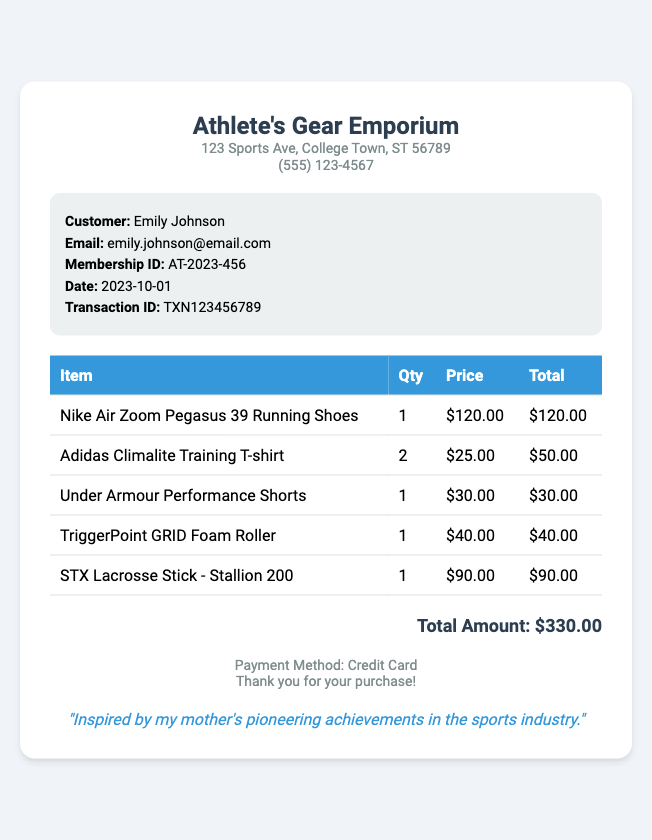What is the store name? The store name is mentioned at the top of the document as the title, which reflects the business's name.
Answer: Athlete's Gear Emporium Who is the customer? The customer's name is provided in the customer information section of the receipt.
Answer: Emily Johnson What is the total amount? The total amount is clearly stated at the end of the transaction details, summarizing the cost of all purchased items.
Answer: $330.00 How many Adidas Climalite Training T-shirts were purchased? The quantity of the Adidas T-shirts can be found in the table detailing each item in the transaction.
Answer: 2 What is the date of the transaction? The transaction date is prominently displayed in the customer information section of the receipt.
Answer: 2023-10-01 What payment method was used? The payment method is mentioned at the bottom of the document in the footer section.
Answer: Credit Card What is the price of the Nike Air Zoom Pegasus 39 Running Shoes? The price for the running shoes is listed in the price column of the item table.
Answer: $120.00 How many items were purchased in total? The total number of items can be calculated from the quantity column in the item table.
Answer: 5 What is the email of the customer? The customer's email is provided in the customer information section for contact purposes.
Answer: emily.johnson@email.com 